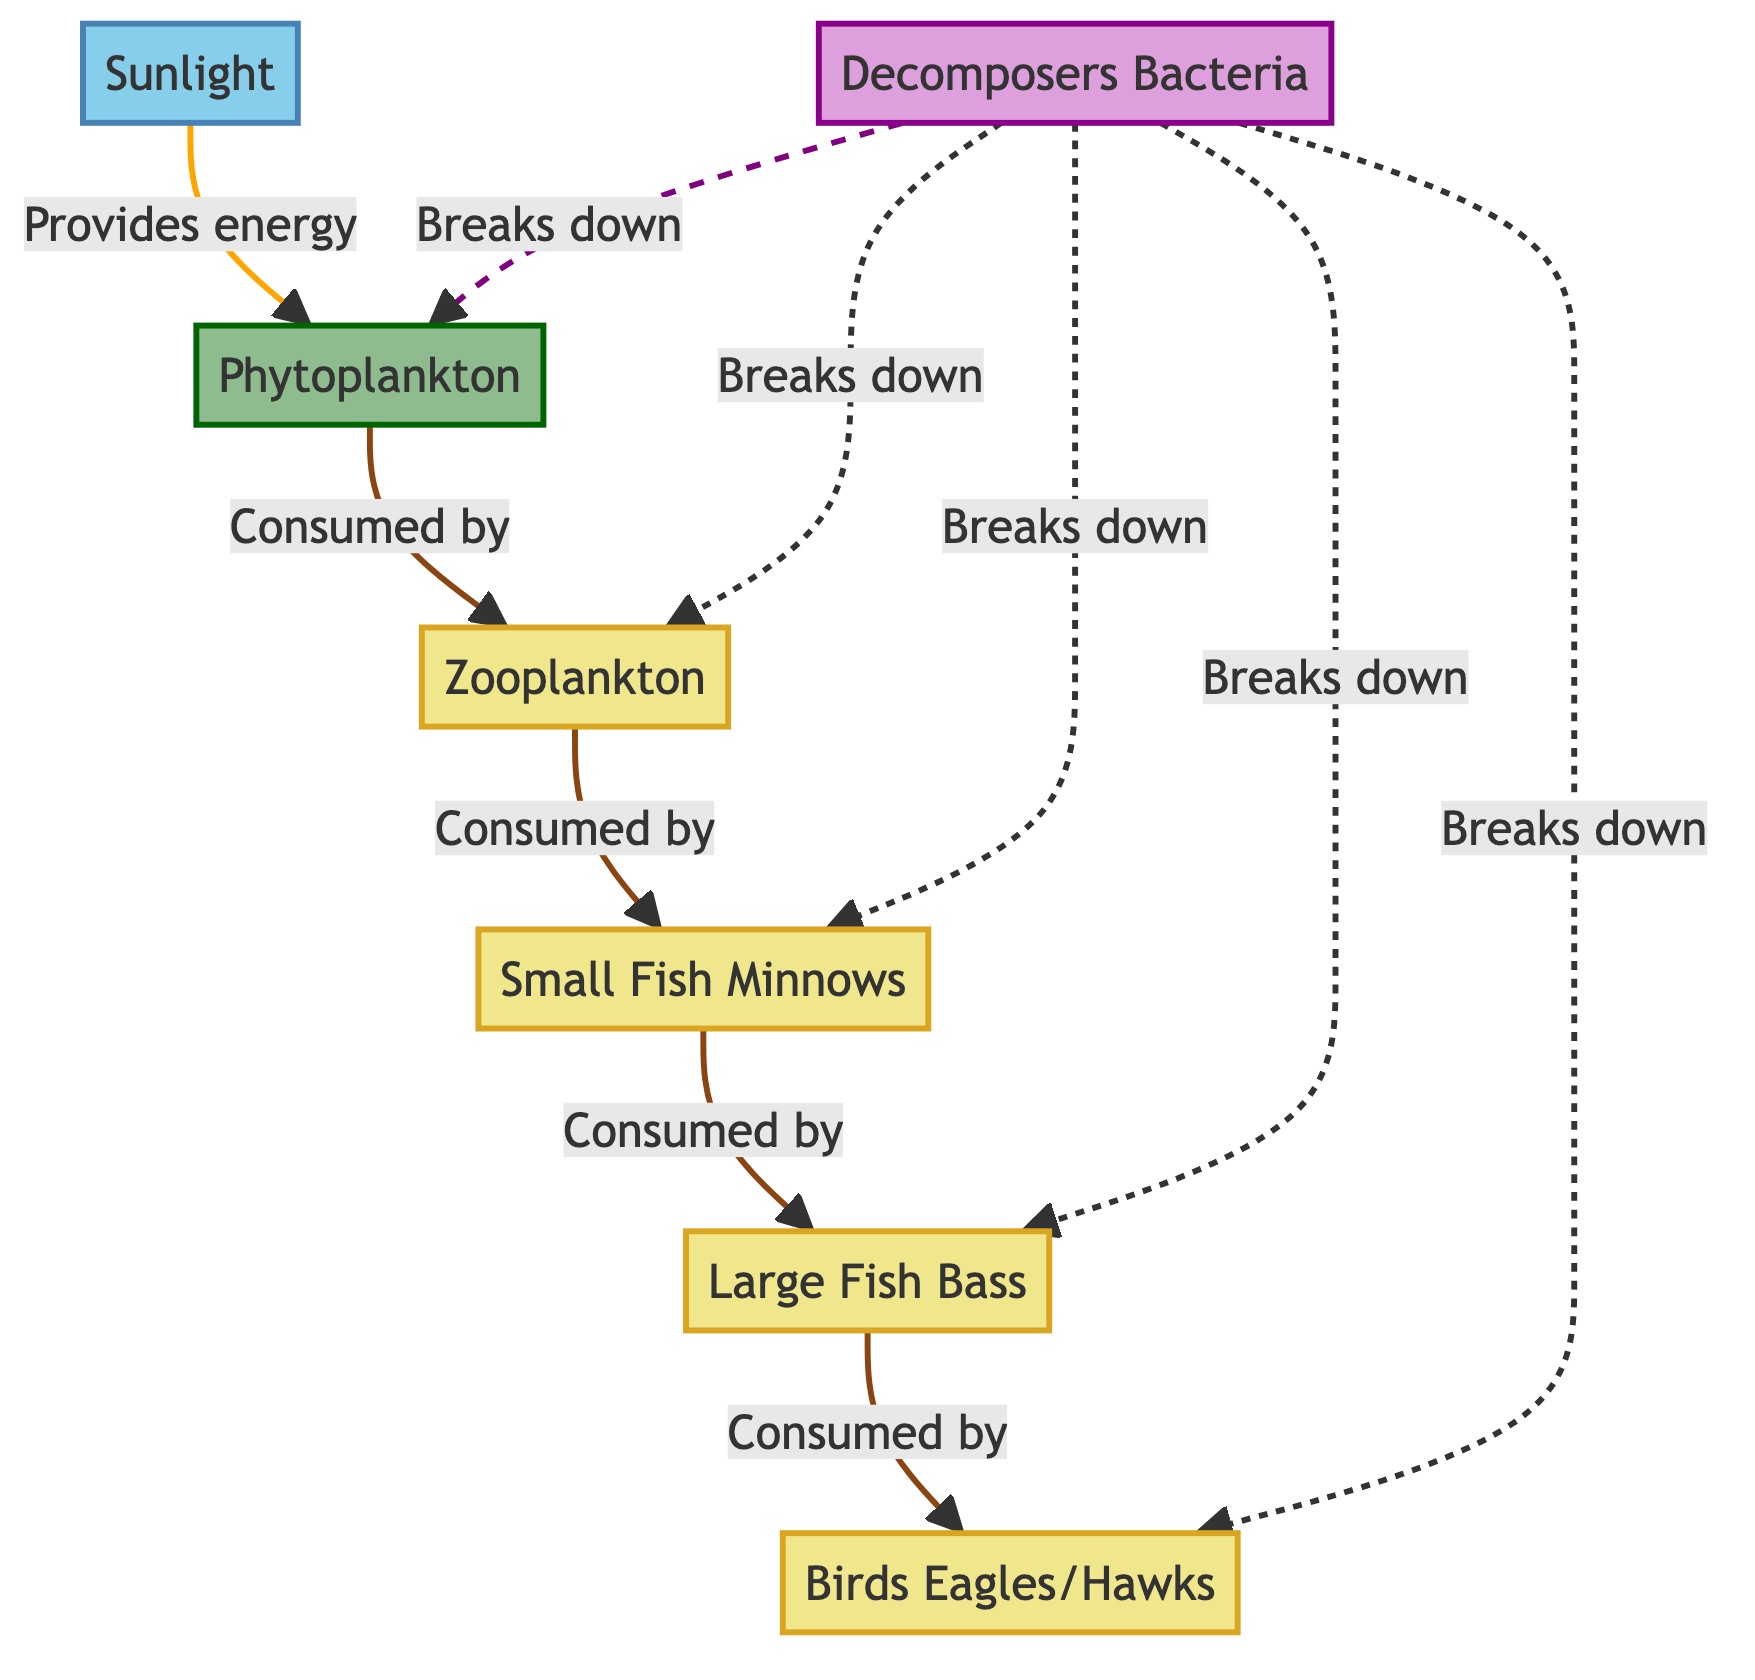What is the primary energy source for the food chain? The diagram indicates that sunlight is at the top of the food chain and is the first node, showing that it provides energy to phytoplankton, which is the primary producer.
Answer: Sunlight Which organism is consumed by small fish minnows? The diagram shows a direct arrow from zooplankton to small fish minnows, indicating that small fish minnows consume zooplankton.
Answer: Zooplankton How many consumer levels are present in the food chain? The food chain includes small fish minnows, large fish bass, and birds (eagles/hawks), which are all consumers. Counting these nodes leads to three distinct consumer levels.
Answer: 3 What role do decomposers play in the food chain? The diagram shows decomposers (bacteria) are connected to all organisms through a dashed line, indicating that they break down the organic matter from all levels of the food chain.
Answer: Break down Which consumer is at the top of the food chain? In the diagram, birds (eagles/hawks) are shown at the final position of consumption, indicating that they are the top consumers in this food chain.
Answer: Birds Eagles/Hawks What type of producers are present in the food chain? The diagram identifies phytoplankton as the only producer in this freshwater fish food chain, highlighting its role as the primary source of energy for consumers.
Answer: Phytoplankton What is the total number of nodes in the diagram? The diagram lists six distinct nodes: Sunlight, Phytoplankton, Zooplankton, Small Fish Minnows, Large Fish Bass, and Birds Eagles/Hawks, in addition to the decomposers. Counting each gives a total of seven nodes.
Answer: 7 Which organism acts as a primary producer? Referring to the diagram, phytoplankton is marked as the primary producer, as it derives energy from sunlight and serves as the base for the food chain.
Answer: Phytoplankton 